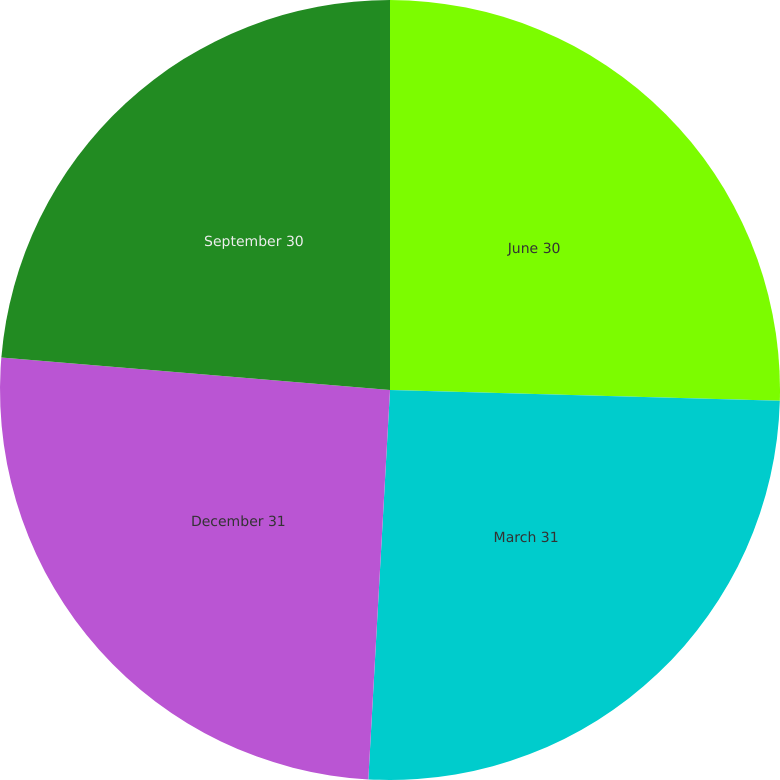<chart> <loc_0><loc_0><loc_500><loc_500><pie_chart><fcel>June 30<fcel>March 31<fcel>December 31<fcel>September 30<nl><fcel>25.44%<fcel>25.44%<fcel>25.44%<fcel>23.67%<nl></chart> 